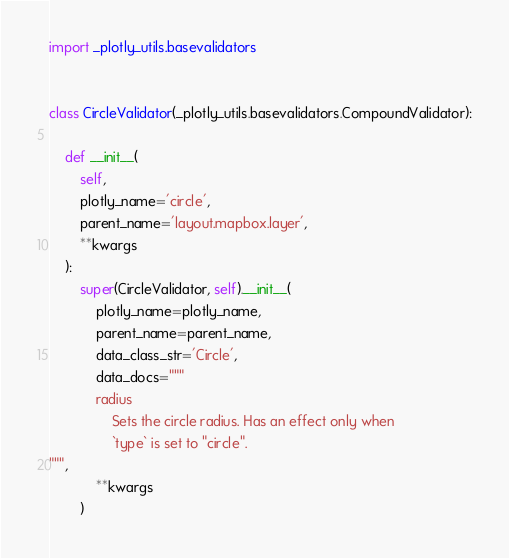Convert code to text. <code><loc_0><loc_0><loc_500><loc_500><_Python_>import _plotly_utils.basevalidators


class CircleValidator(_plotly_utils.basevalidators.CompoundValidator):

    def __init__(
        self,
        plotly_name='circle',
        parent_name='layout.mapbox.layer',
        **kwargs
    ):
        super(CircleValidator, self).__init__(
            plotly_name=plotly_name,
            parent_name=parent_name,
            data_class_str='Circle',
            data_docs="""
            radius
                Sets the circle radius. Has an effect only when
                `type` is set to "circle".
""",
            **kwargs
        )
</code> 